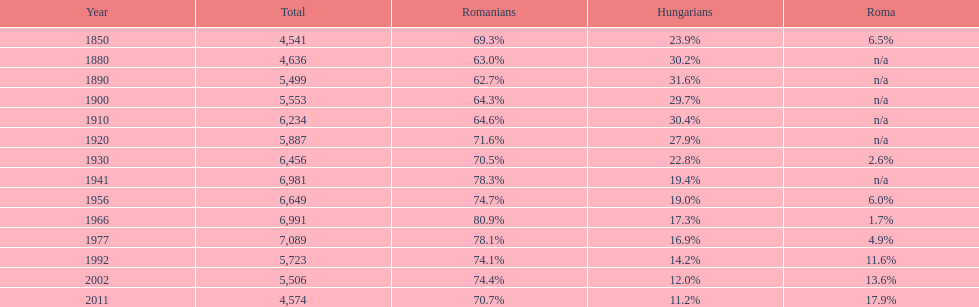In what year did hungarians constitute the largest percentage? 1890. 